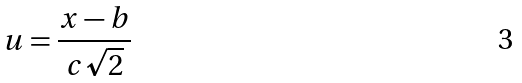Convert formula to latex. <formula><loc_0><loc_0><loc_500><loc_500>u = \frac { x - b } { c \sqrt { 2 } }</formula> 